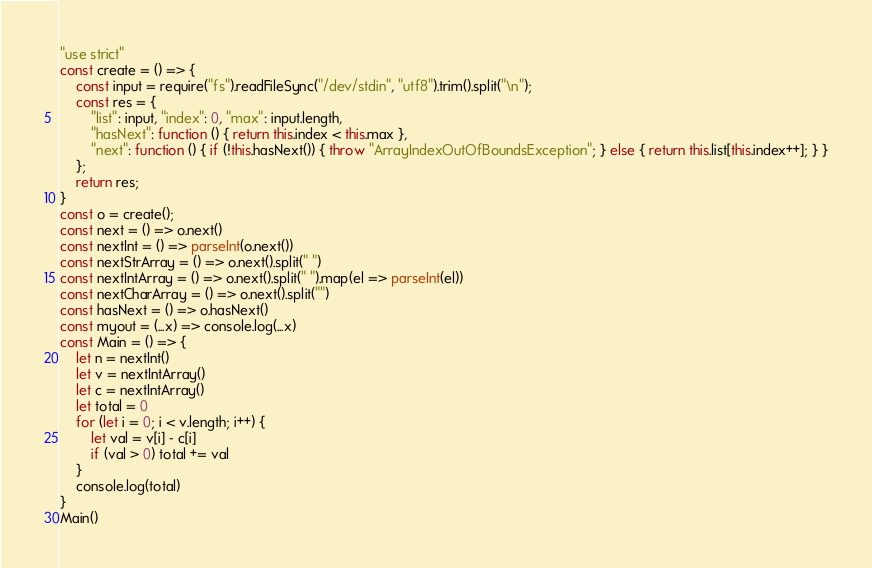Convert code to text. <code><loc_0><loc_0><loc_500><loc_500><_JavaScript_>"use strict"
const create = () => {
    const input = require("fs").readFileSync("/dev/stdin", "utf8").trim().split("\n");
    const res = {
        "list": input, "index": 0, "max": input.length,
        "hasNext": function () { return this.index < this.max },
        "next": function () { if (!this.hasNext()) { throw "ArrayIndexOutOfBoundsException"; } else { return this.list[this.index++]; } }
    };
    return res;
}
const o = create();
const next = () => o.next()
const nextInt = () => parseInt(o.next())
const nextStrArray = () => o.next().split(" ")
const nextIntArray = () => o.next().split(" ").map(el => parseInt(el))
const nextCharArray = () => o.next().split("")
const hasNext = () => o.hasNext()
const myout = (...x) => console.log(...x)
const Main = () => {
    let n = nextInt()
    let v = nextIntArray()
    let c = nextIntArray()
    let total = 0
    for (let i = 0; i < v.length; i++) {
        let val = v[i] - c[i]
        if (val > 0) total += val
    }
    console.log(total)
}
Main()
</code> 